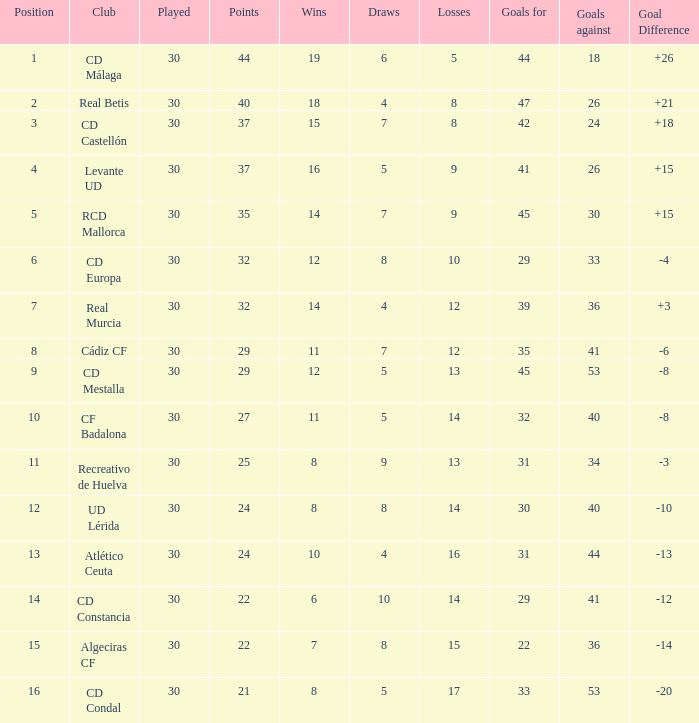What is the goals for when played is larger than 30? None. 